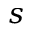<formula> <loc_0><loc_0><loc_500><loc_500>s</formula> 